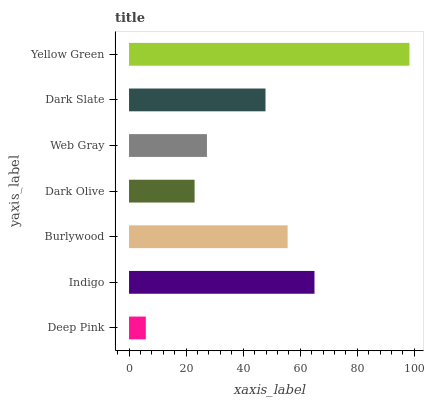Is Deep Pink the minimum?
Answer yes or no. Yes. Is Yellow Green the maximum?
Answer yes or no. Yes. Is Indigo the minimum?
Answer yes or no. No. Is Indigo the maximum?
Answer yes or no. No. Is Indigo greater than Deep Pink?
Answer yes or no. Yes. Is Deep Pink less than Indigo?
Answer yes or no. Yes. Is Deep Pink greater than Indigo?
Answer yes or no. No. Is Indigo less than Deep Pink?
Answer yes or no. No. Is Dark Slate the high median?
Answer yes or no. Yes. Is Dark Slate the low median?
Answer yes or no. Yes. Is Dark Olive the high median?
Answer yes or no. No. Is Web Gray the low median?
Answer yes or no. No. 